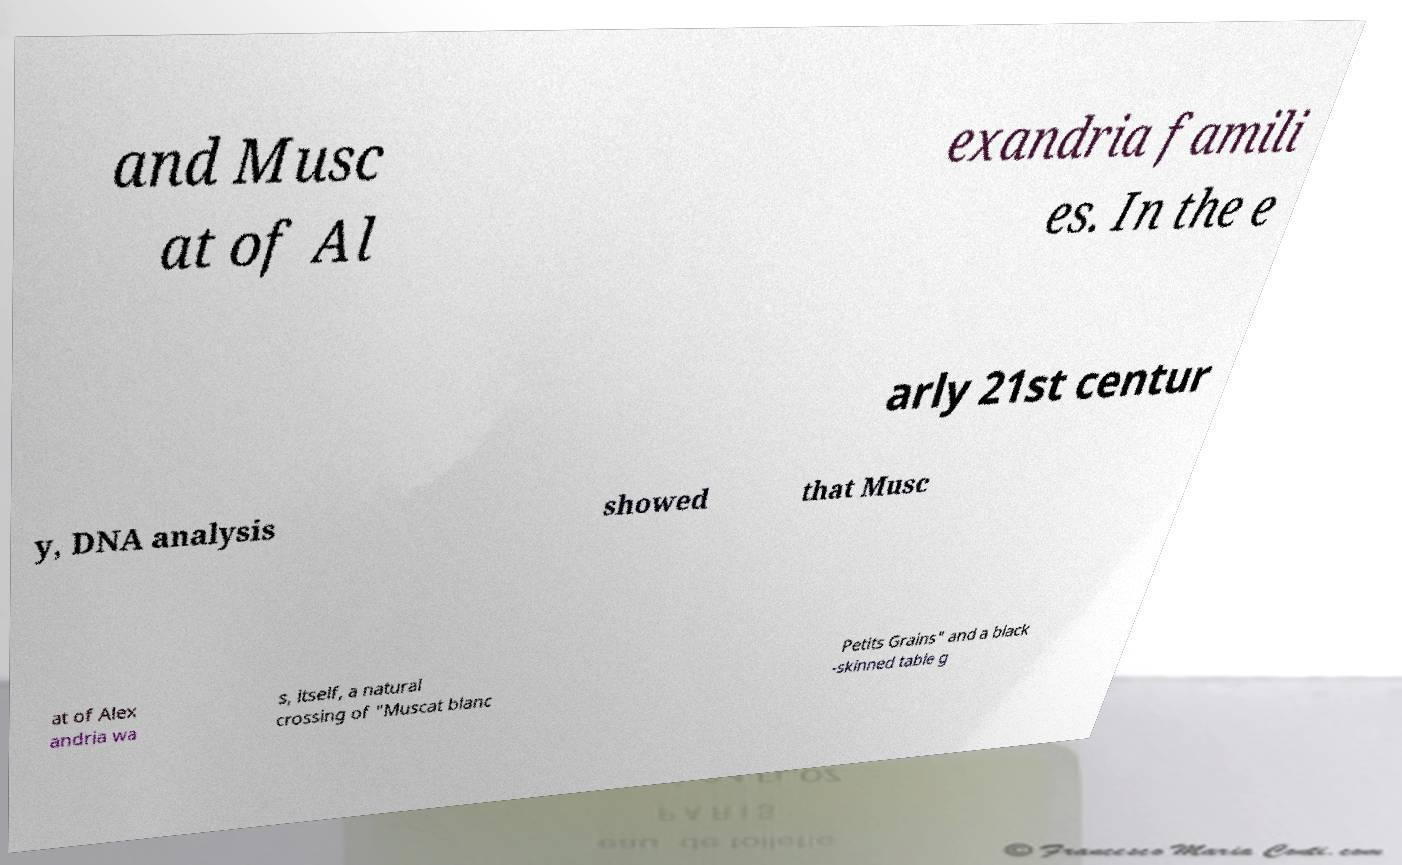What messages or text are displayed in this image? I need them in a readable, typed format. and Musc at of Al exandria famili es. In the e arly 21st centur y, DNA analysis showed that Musc at of Alex andria wa s, itself, a natural crossing of "Muscat blanc Petits Grains" and a black -skinned table g 